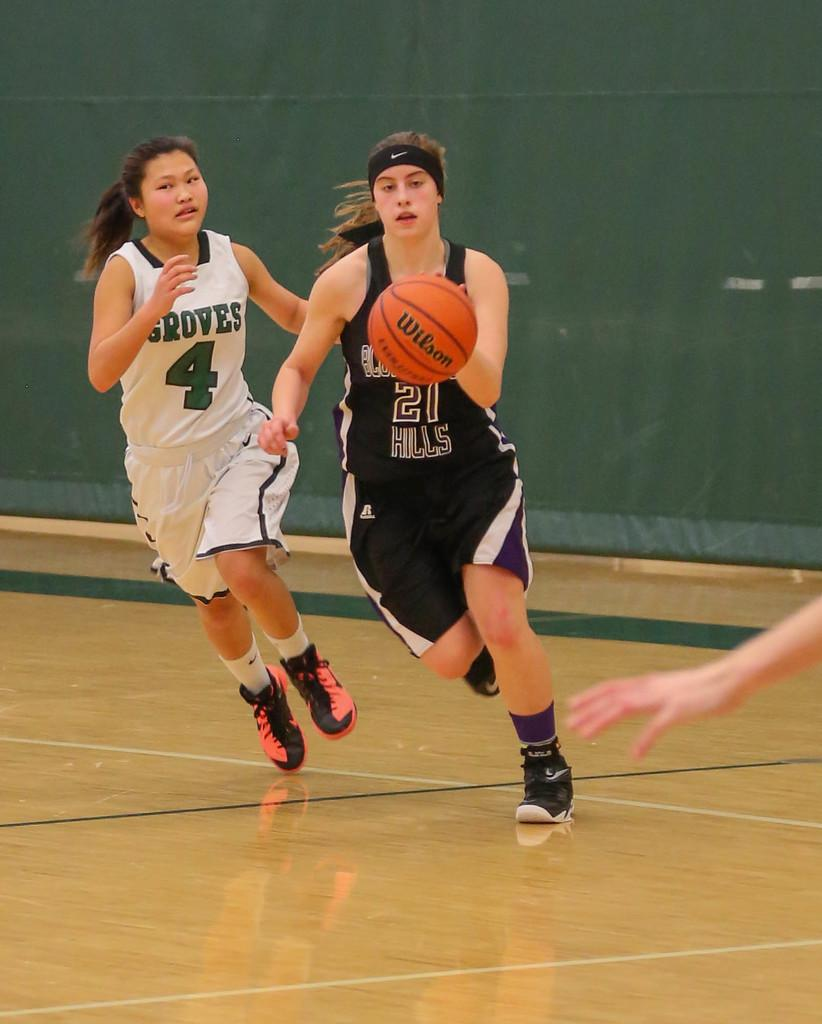<image>
Relay a brief, clear account of the picture shown. Two girls competing in a basketball game numbered 4 and 21. 